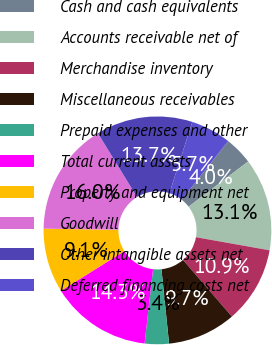Convert chart to OTSL. <chart><loc_0><loc_0><loc_500><loc_500><pie_chart><fcel>Cash and cash equivalents<fcel>Accounts receivable net of<fcel>Merchandise inventory<fcel>Miscellaneous receivables<fcel>Prepaid expenses and other<fcel>Total current assets<fcel>Property and equipment net<fcel>Goodwill<fcel>Other intangible assets net<fcel>Deferred financing costs net<nl><fcel>4.0%<fcel>13.14%<fcel>10.86%<fcel>9.71%<fcel>3.43%<fcel>14.29%<fcel>9.14%<fcel>16.0%<fcel>13.71%<fcel>5.71%<nl></chart> 